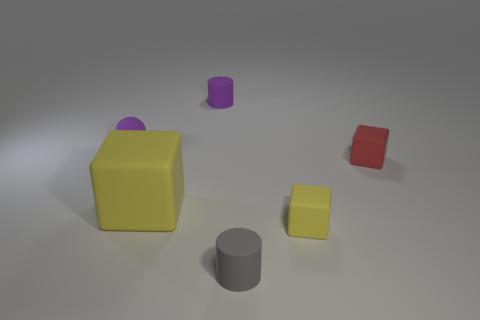Subtract all small cubes. How many cubes are left? 1 Add 1 blue cylinders. How many objects exist? 7 Subtract all cylinders. How many objects are left? 4 Add 1 red matte things. How many red matte things are left? 2 Add 6 big metallic things. How many big metallic things exist? 6 Subtract 0 purple cubes. How many objects are left? 6 Subtract all large things. Subtract all green rubber cubes. How many objects are left? 5 